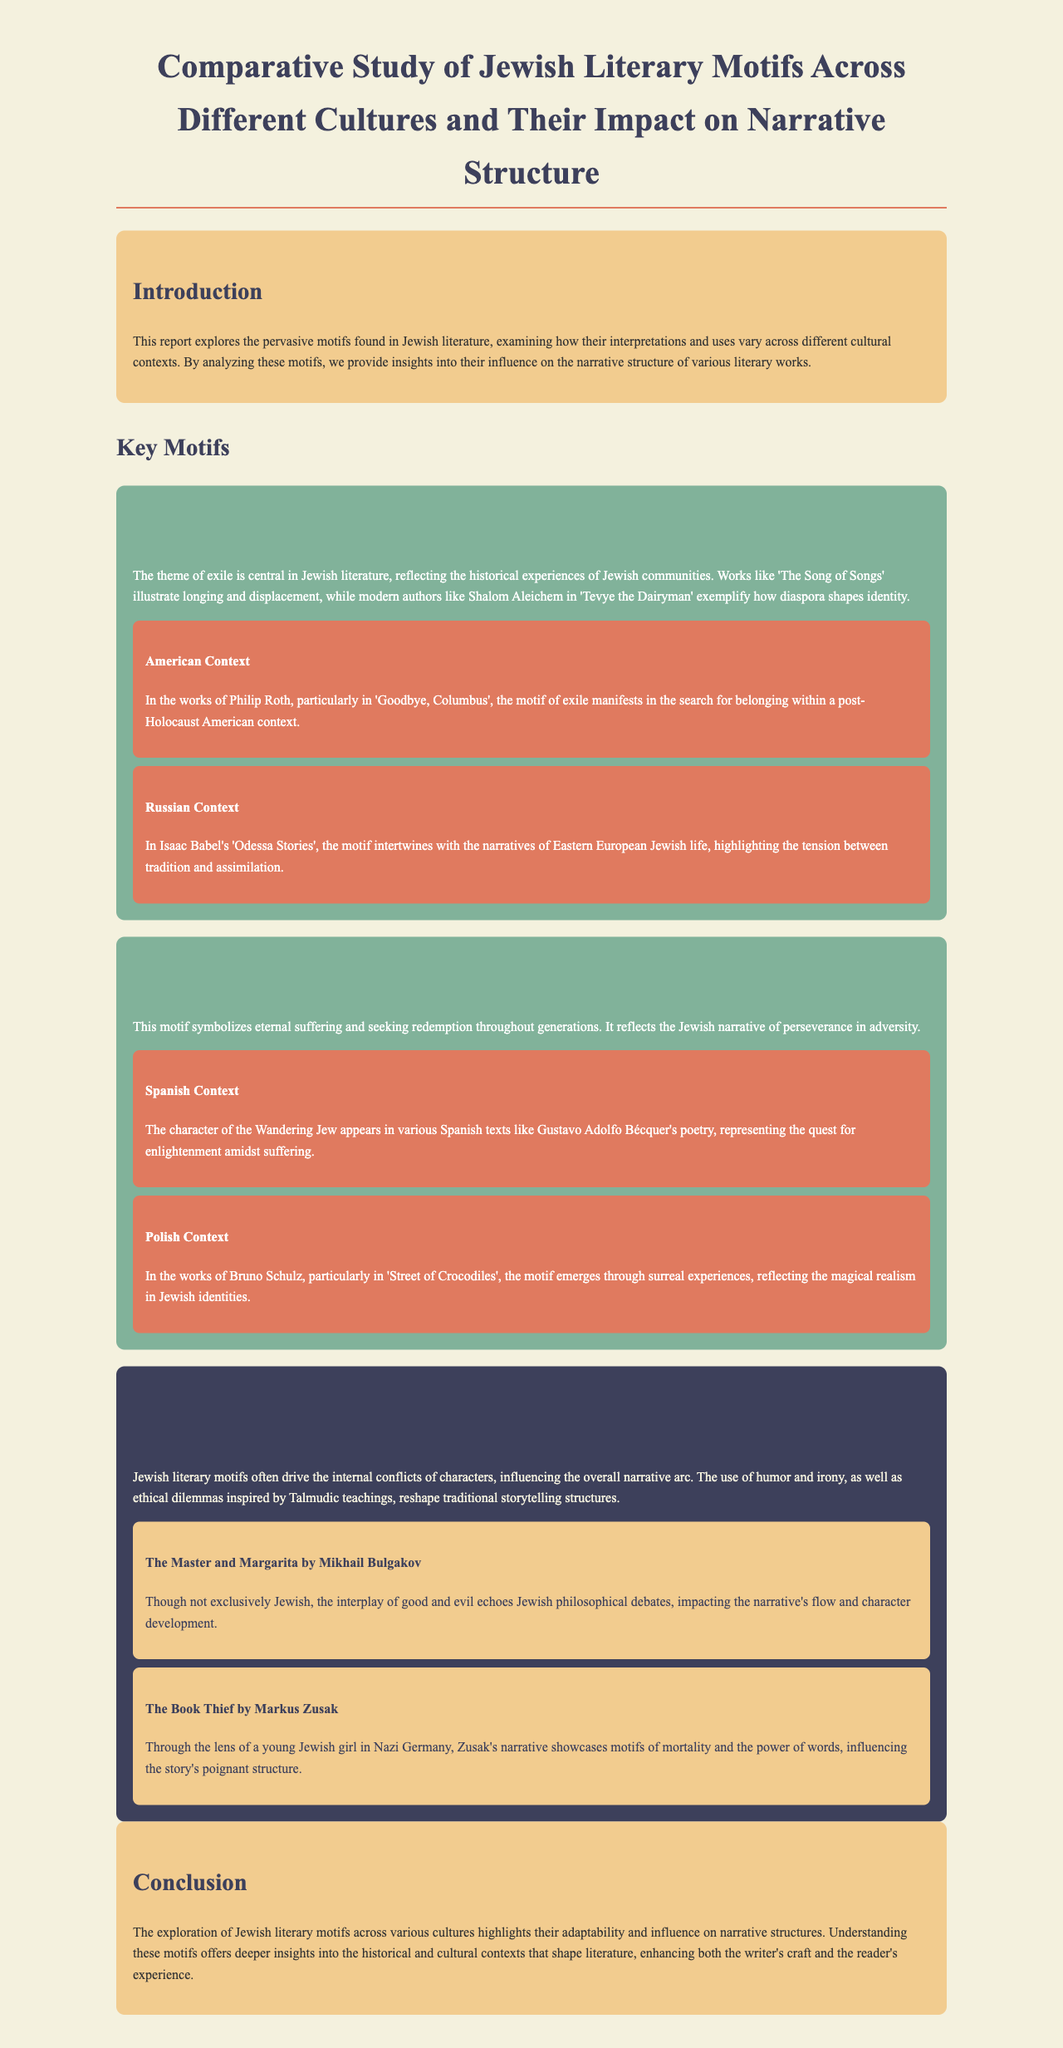What is the title of the report? The title is a key identifier of the document and is stated in the heading.
Answer: Comparative Study of Jewish Literary Motifs Across Different Cultures and Their Impact on Narrative Structure What are the two key motifs discussed in the report? The report outlines two primary motifs, highlighting the focus of the analysis.
Answer: Exile and Diaspora; The Wandering Jew Which author wrote 'Tevye the Dairyman'? The document provides examples of authors associated with specific motifs, aiding in identifying key figures in Jewish literature.
Answer: Shalom Aleichem What cultural context does Philip Roth's work relate to the motif of exile? Understanding the cultural context allows readers to see how motifs manifest in different settings, which is detailed in the report.
Answer: American Context What narrative structure influence is mentioned in the impact section related to Jewish literary motifs? The document describes how motifs affect the storytelling approach in literature, indicating their significance.
Answer: Internal conflicts of characters In which work does the motif of mortality appear through the lens of a Jewish girl? This question connects a specific motif to a text, demonstrating the application of motifs in narrative structures discussed in the report.
Answer: The Book Thief What type of literature does the Wandering Jew motif appear in, according to the Spanish context? The report specifies the kinds of literature where certain motifs can be found, which enriches understanding of cultural implications.
Answer: Poetry Which literary work by Mikhail Bulgakov is referenced in the impact section? This question identifies specific texts that illustrate the themes discussed, providing concrete examples of narrative influence.
Answer: The Master and Margarita 